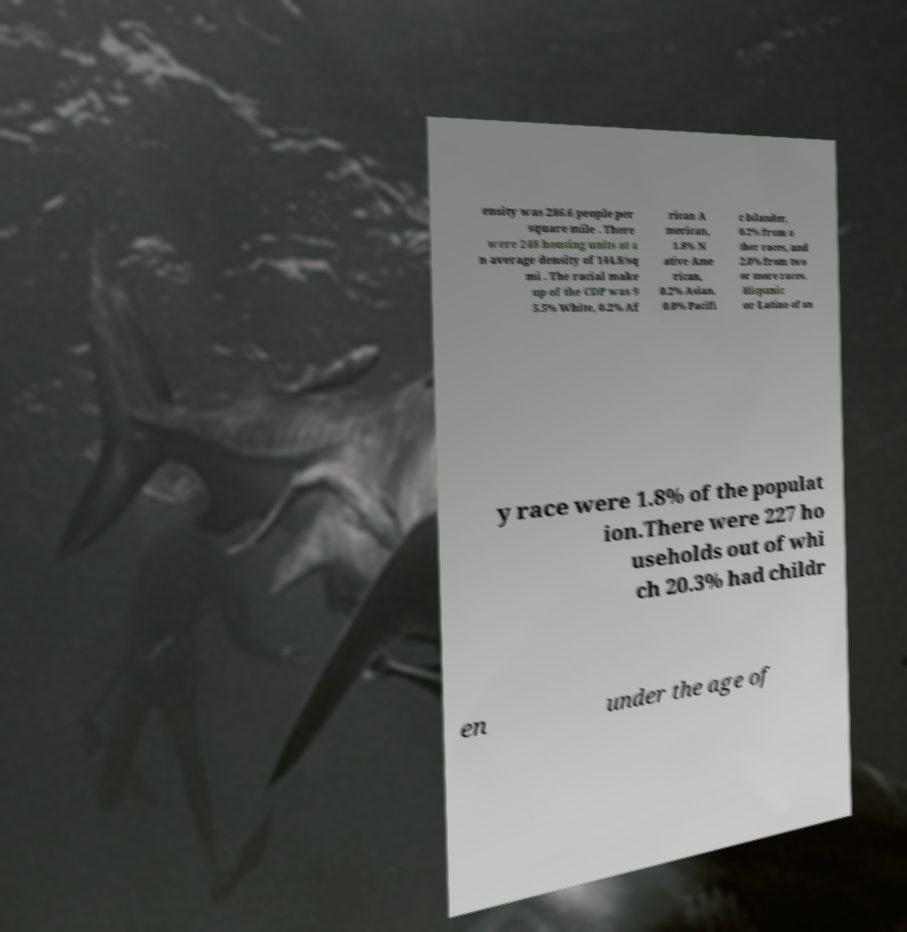Can you read and provide the text displayed in the image?This photo seems to have some interesting text. Can you extract and type it out for me? ensity was 286.6 people per square mile . There were 248 housing units at a n average density of 144.8/sq mi . The racial make up of the CDP was 9 5.5% White, 0.2% Af rican A merican, 1.8% N ative Ame rican, 0.2% Asian, 0.0% Pacifi c Islander, 0.2% from o ther races, and 2.0% from two or more races. Hispanic or Latino of an y race were 1.8% of the populat ion.There were 227 ho useholds out of whi ch 20.3% had childr en under the age of 